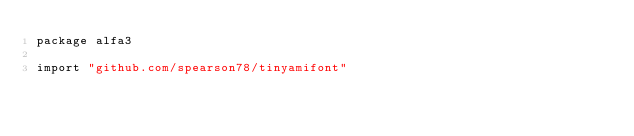Convert code to text. <code><loc_0><loc_0><loc_500><loc_500><_Go_>package alfa3

import "github.com/spearson78/tinyamifont"
</code> 